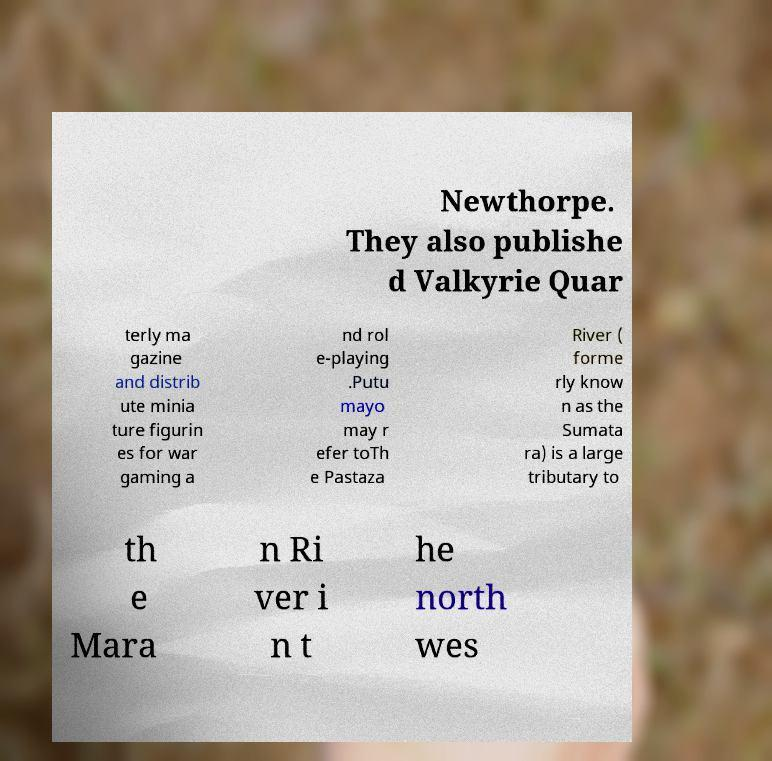Can you accurately transcribe the text from the provided image for me? Newthorpe. They also publishe d Valkyrie Quar terly ma gazine and distrib ute minia ture figurin es for war gaming a nd rol e-playing .Putu mayo may r efer toTh e Pastaza River ( forme rly know n as the Sumata ra) is a large tributary to th e Mara n Ri ver i n t he north wes 